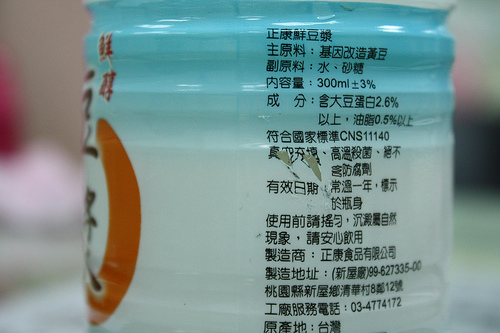<image>
Is there a bottle behind the bottle space? No. The bottle is not behind the bottle space. From this viewpoint, the bottle appears to be positioned elsewhere in the scene. 